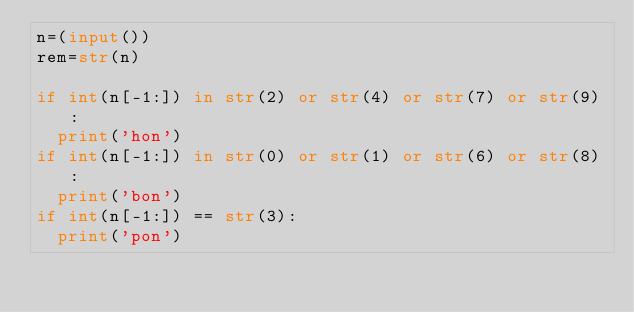Convert code to text. <code><loc_0><loc_0><loc_500><loc_500><_Python_>n=(input())
rem=str(n)

if int(n[-1:]) in str(2) or str(4) or str(7) or str(9):
  print('hon')
if int(n[-1:]) in str(0) or str(1) or str(6) or str(8):
  print('bon')
if int(n[-1:]) == str(3):
  print('pon')
  
</code> 